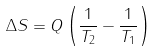<formula> <loc_0><loc_0><loc_500><loc_500>\Delta S = Q \left ( { \frac { 1 } { T _ { 2 } } } - { \frac { 1 } { T _ { 1 } } } \right )</formula> 